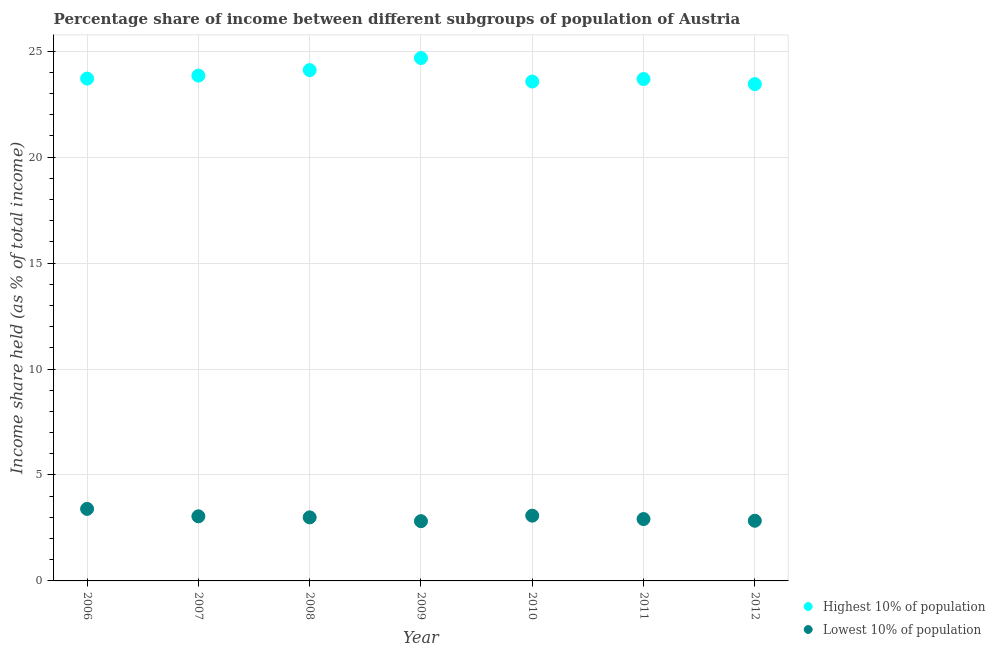How many different coloured dotlines are there?
Make the answer very short. 2. Is the number of dotlines equal to the number of legend labels?
Provide a short and direct response. Yes. What is the income share held by highest 10% of the population in 2010?
Ensure brevity in your answer.  23.57. Across all years, what is the maximum income share held by highest 10% of the population?
Give a very brief answer. 24.68. Across all years, what is the minimum income share held by highest 10% of the population?
Ensure brevity in your answer.  23.45. In which year was the income share held by highest 10% of the population maximum?
Ensure brevity in your answer.  2009. What is the total income share held by highest 10% of the population in the graph?
Offer a very short reply. 167.06. What is the difference between the income share held by lowest 10% of the population in 2008 and that in 2011?
Offer a very short reply. 0.08. What is the difference between the income share held by lowest 10% of the population in 2011 and the income share held by highest 10% of the population in 2012?
Your response must be concise. -20.53. What is the average income share held by lowest 10% of the population per year?
Your answer should be compact. 3.02. In the year 2007, what is the difference between the income share held by lowest 10% of the population and income share held by highest 10% of the population?
Your answer should be very brief. -20.8. What is the ratio of the income share held by highest 10% of the population in 2007 to that in 2009?
Your response must be concise. 0.97. Is the difference between the income share held by lowest 10% of the population in 2011 and 2012 greater than the difference between the income share held by highest 10% of the population in 2011 and 2012?
Offer a very short reply. No. What is the difference between the highest and the second highest income share held by highest 10% of the population?
Your answer should be compact. 0.57. What is the difference between the highest and the lowest income share held by lowest 10% of the population?
Provide a succinct answer. 0.58. In how many years, is the income share held by highest 10% of the population greater than the average income share held by highest 10% of the population taken over all years?
Keep it short and to the point. 2. How many dotlines are there?
Offer a terse response. 2. Are the values on the major ticks of Y-axis written in scientific E-notation?
Your response must be concise. No. Does the graph contain any zero values?
Give a very brief answer. No. Does the graph contain grids?
Your answer should be very brief. Yes. Where does the legend appear in the graph?
Your response must be concise. Bottom right. How many legend labels are there?
Offer a terse response. 2. What is the title of the graph?
Offer a terse response. Percentage share of income between different subgroups of population of Austria. What is the label or title of the X-axis?
Offer a terse response. Year. What is the label or title of the Y-axis?
Keep it short and to the point. Income share held (as % of total income). What is the Income share held (as % of total income) of Highest 10% of population in 2006?
Keep it short and to the point. 23.71. What is the Income share held (as % of total income) of Lowest 10% of population in 2006?
Give a very brief answer. 3.4. What is the Income share held (as % of total income) in Highest 10% of population in 2007?
Give a very brief answer. 23.85. What is the Income share held (as % of total income) of Lowest 10% of population in 2007?
Your answer should be compact. 3.05. What is the Income share held (as % of total income) of Highest 10% of population in 2008?
Keep it short and to the point. 24.11. What is the Income share held (as % of total income) in Lowest 10% of population in 2008?
Provide a short and direct response. 3. What is the Income share held (as % of total income) of Highest 10% of population in 2009?
Give a very brief answer. 24.68. What is the Income share held (as % of total income) of Lowest 10% of population in 2009?
Ensure brevity in your answer.  2.82. What is the Income share held (as % of total income) of Highest 10% of population in 2010?
Make the answer very short. 23.57. What is the Income share held (as % of total income) in Lowest 10% of population in 2010?
Ensure brevity in your answer.  3.08. What is the Income share held (as % of total income) in Highest 10% of population in 2011?
Your answer should be compact. 23.69. What is the Income share held (as % of total income) of Lowest 10% of population in 2011?
Your answer should be compact. 2.92. What is the Income share held (as % of total income) of Highest 10% of population in 2012?
Your answer should be very brief. 23.45. What is the Income share held (as % of total income) in Lowest 10% of population in 2012?
Your answer should be compact. 2.84. Across all years, what is the maximum Income share held (as % of total income) in Highest 10% of population?
Make the answer very short. 24.68. Across all years, what is the maximum Income share held (as % of total income) in Lowest 10% of population?
Provide a succinct answer. 3.4. Across all years, what is the minimum Income share held (as % of total income) of Highest 10% of population?
Ensure brevity in your answer.  23.45. Across all years, what is the minimum Income share held (as % of total income) of Lowest 10% of population?
Offer a very short reply. 2.82. What is the total Income share held (as % of total income) of Highest 10% of population in the graph?
Offer a terse response. 167.06. What is the total Income share held (as % of total income) in Lowest 10% of population in the graph?
Provide a short and direct response. 21.11. What is the difference between the Income share held (as % of total income) of Highest 10% of population in 2006 and that in 2007?
Make the answer very short. -0.14. What is the difference between the Income share held (as % of total income) in Lowest 10% of population in 2006 and that in 2007?
Make the answer very short. 0.35. What is the difference between the Income share held (as % of total income) in Lowest 10% of population in 2006 and that in 2008?
Offer a terse response. 0.4. What is the difference between the Income share held (as % of total income) of Highest 10% of population in 2006 and that in 2009?
Provide a short and direct response. -0.97. What is the difference between the Income share held (as % of total income) in Lowest 10% of population in 2006 and that in 2009?
Offer a very short reply. 0.58. What is the difference between the Income share held (as % of total income) in Highest 10% of population in 2006 and that in 2010?
Make the answer very short. 0.14. What is the difference between the Income share held (as % of total income) of Lowest 10% of population in 2006 and that in 2010?
Your answer should be compact. 0.32. What is the difference between the Income share held (as % of total income) of Lowest 10% of population in 2006 and that in 2011?
Ensure brevity in your answer.  0.48. What is the difference between the Income share held (as % of total income) in Highest 10% of population in 2006 and that in 2012?
Offer a terse response. 0.26. What is the difference between the Income share held (as % of total income) in Lowest 10% of population in 2006 and that in 2012?
Your response must be concise. 0.56. What is the difference between the Income share held (as % of total income) of Highest 10% of population in 2007 and that in 2008?
Make the answer very short. -0.26. What is the difference between the Income share held (as % of total income) in Highest 10% of population in 2007 and that in 2009?
Give a very brief answer. -0.83. What is the difference between the Income share held (as % of total income) in Lowest 10% of population in 2007 and that in 2009?
Make the answer very short. 0.23. What is the difference between the Income share held (as % of total income) in Highest 10% of population in 2007 and that in 2010?
Provide a short and direct response. 0.28. What is the difference between the Income share held (as % of total income) in Lowest 10% of population in 2007 and that in 2010?
Your answer should be very brief. -0.03. What is the difference between the Income share held (as % of total income) of Highest 10% of population in 2007 and that in 2011?
Offer a very short reply. 0.16. What is the difference between the Income share held (as % of total income) of Lowest 10% of population in 2007 and that in 2011?
Make the answer very short. 0.13. What is the difference between the Income share held (as % of total income) in Lowest 10% of population in 2007 and that in 2012?
Make the answer very short. 0.21. What is the difference between the Income share held (as % of total income) in Highest 10% of population in 2008 and that in 2009?
Keep it short and to the point. -0.57. What is the difference between the Income share held (as % of total income) of Lowest 10% of population in 2008 and that in 2009?
Make the answer very short. 0.18. What is the difference between the Income share held (as % of total income) of Highest 10% of population in 2008 and that in 2010?
Your answer should be very brief. 0.54. What is the difference between the Income share held (as % of total income) in Lowest 10% of population in 2008 and that in 2010?
Ensure brevity in your answer.  -0.08. What is the difference between the Income share held (as % of total income) in Highest 10% of population in 2008 and that in 2011?
Give a very brief answer. 0.42. What is the difference between the Income share held (as % of total income) of Highest 10% of population in 2008 and that in 2012?
Give a very brief answer. 0.66. What is the difference between the Income share held (as % of total income) of Lowest 10% of population in 2008 and that in 2012?
Provide a short and direct response. 0.16. What is the difference between the Income share held (as % of total income) of Highest 10% of population in 2009 and that in 2010?
Provide a succinct answer. 1.11. What is the difference between the Income share held (as % of total income) of Lowest 10% of population in 2009 and that in 2010?
Provide a succinct answer. -0.26. What is the difference between the Income share held (as % of total income) in Lowest 10% of population in 2009 and that in 2011?
Ensure brevity in your answer.  -0.1. What is the difference between the Income share held (as % of total income) of Highest 10% of population in 2009 and that in 2012?
Provide a succinct answer. 1.23. What is the difference between the Income share held (as % of total income) in Lowest 10% of population in 2009 and that in 2012?
Offer a very short reply. -0.02. What is the difference between the Income share held (as % of total income) of Highest 10% of population in 2010 and that in 2011?
Offer a very short reply. -0.12. What is the difference between the Income share held (as % of total income) of Lowest 10% of population in 2010 and that in 2011?
Offer a terse response. 0.16. What is the difference between the Income share held (as % of total income) of Highest 10% of population in 2010 and that in 2012?
Your response must be concise. 0.12. What is the difference between the Income share held (as % of total income) in Lowest 10% of population in 2010 and that in 2012?
Keep it short and to the point. 0.24. What is the difference between the Income share held (as % of total income) of Highest 10% of population in 2011 and that in 2012?
Give a very brief answer. 0.24. What is the difference between the Income share held (as % of total income) in Lowest 10% of population in 2011 and that in 2012?
Your answer should be compact. 0.08. What is the difference between the Income share held (as % of total income) of Highest 10% of population in 2006 and the Income share held (as % of total income) of Lowest 10% of population in 2007?
Your answer should be very brief. 20.66. What is the difference between the Income share held (as % of total income) of Highest 10% of population in 2006 and the Income share held (as % of total income) of Lowest 10% of population in 2008?
Provide a succinct answer. 20.71. What is the difference between the Income share held (as % of total income) of Highest 10% of population in 2006 and the Income share held (as % of total income) of Lowest 10% of population in 2009?
Ensure brevity in your answer.  20.89. What is the difference between the Income share held (as % of total income) of Highest 10% of population in 2006 and the Income share held (as % of total income) of Lowest 10% of population in 2010?
Ensure brevity in your answer.  20.63. What is the difference between the Income share held (as % of total income) in Highest 10% of population in 2006 and the Income share held (as % of total income) in Lowest 10% of population in 2011?
Your answer should be very brief. 20.79. What is the difference between the Income share held (as % of total income) in Highest 10% of population in 2006 and the Income share held (as % of total income) in Lowest 10% of population in 2012?
Provide a succinct answer. 20.87. What is the difference between the Income share held (as % of total income) in Highest 10% of population in 2007 and the Income share held (as % of total income) in Lowest 10% of population in 2008?
Ensure brevity in your answer.  20.85. What is the difference between the Income share held (as % of total income) of Highest 10% of population in 2007 and the Income share held (as % of total income) of Lowest 10% of population in 2009?
Provide a short and direct response. 21.03. What is the difference between the Income share held (as % of total income) of Highest 10% of population in 2007 and the Income share held (as % of total income) of Lowest 10% of population in 2010?
Make the answer very short. 20.77. What is the difference between the Income share held (as % of total income) of Highest 10% of population in 2007 and the Income share held (as % of total income) of Lowest 10% of population in 2011?
Give a very brief answer. 20.93. What is the difference between the Income share held (as % of total income) of Highest 10% of population in 2007 and the Income share held (as % of total income) of Lowest 10% of population in 2012?
Your response must be concise. 21.01. What is the difference between the Income share held (as % of total income) of Highest 10% of population in 2008 and the Income share held (as % of total income) of Lowest 10% of population in 2009?
Your answer should be very brief. 21.29. What is the difference between the Income share held (as % of total income) in Highest 10% of population in 2008 and the Income share held (as % of total income) in Lowest 10% of population in 2010?
Your answer should be very brief. 21.03. What is the difference between the Income share held (as % of total income) of Highest 10% of population in 2008 and the Income share held (as % of total income) of Lowest 10% of population in 2011?
Keep it short and to the point. 21.19. What is the difference between the Income share held (as % of total income) of Highest 10% of population in 2008 and the Income share held (as % of total income) of Lowest 10% of population in 2012?
Your answer should be compact. 21.27. What is the difference between the Income share held (as % of total income) in Highest 10% of population in 2009 and the Income share held (as % of total income) in Lowest 10% of population in 2010?
Offer a very short reply. 21.6. What is the difference between the Income share held (as % of total income) in Highest 10% of population in 2009 and the Income share held (as % of total income) in Lowest 10% of population in 2011?
Your answer should be very brief. 21.76. What is the difference between the Income share held (as % of total income) of Highest 10% of population in 2009 and the Income share held (as % of total income) of Lowest 10% of population in 2012?
Make the answer very short. 21.84. What is the difference between the Income share held (as % of total income) of Highest 10% of population in 2010 and the Income share held (as % of total income) of Lowest 10% of population in 2011?
Keep it short and to the point. 20.65. What is the difference between the Income share held (as % of total income) in Highest 10% of population in 2010 and the Income share held (as % of total income) in Lowest 10% of population in 2012?
Offer a terse response. 20.73. What is the difference between the Income share held (as % of total income) in Highest 10% of population in 2011 and the Income share held (as % of total income) in Lowest 10% of population in 2012?
Offer a very short reply. 20.85. What is the average Income share held (as % of total income) of Highest 10% of population per year?
Offer a very short reply. 23.87. What is the average Income share held (as % of total income) of Lowest 10% of population per year?
Keep it short and to the point. 3.02. In the year 2006, what is the difference between the Income share held (as % of total income) of Highest 10% of population and Income share held (as % of total income) of Lowest 10% of population?
Offer a very short reply. 20.31. In the year 2007, what is the difference between the Income share held (as % of total income) of Highest 10% of population and Income share held (as % of total income) of Lowest 10% of population?
Your response must be concise. 20.8. In the year 2008, what is the difference between the Income share held (as % of total income) of Highest 10% of population and Income share held (as % of total income) of Lowest 10% of population?
Provide a succinct answer. 21.11. In the year 2009, what is the difference between the Income share held (as % of total income) in Highest 10% of population and Income share held (as % of total income) in Lowest 10% of population?
Offer a very short reply. 21.86. In the year 2010, what is the difference between the Income share held (as % of total income) in Highest 10% of population and Income share held (as % of total income) in Lowest 10% of population?
Ensure brevity in your answer.  20.49. In the year 2011, what is the difference between the Income share held (as % of total income) in Highest 10% of population and Income share held (as % of total income) in Lowest 10% of population?
Your answer should be very brief. 20.77. In the year 2012, what is the difference between the Income share held (as % of total income) of Highest 10% of population and Income share held (as % of total income) of Lowest 10% of population?
Provide a succinct answer. 20.61. What is the ratio of the Income share held (as % of total income) in Highest 10% of population in 2006 to that in 2007?
Make the answer very short. 0.99. What is the ratio of the Income share held (as % of total income) in Lowest 10% of population in 2006 to that in 2007?
Give a very brief answer. 1.11. What is the ratio of the Income share held (as % of total income) of Highest 10% of population in 2006 to that in 2008?
Provide a short and direct response. 0.98. What is the ratio of the Income share held (as % of total income) in Lowest 10% of population in 2006 to that in 2008?
Make the answer very short. 1.13. What is the ratio of the Income share held (as % of total income) in Highest 10% of population in 2006 to that in 2009?
Provide a succinct answer. 0.96. What is the ratio of the Income share held (as % of total income) of Lowest 10% of population in 2006 to that in 2009?
Offer a terse response. 1.21. What is the ratio of the Income share held (as % of total income) of Highest 10% of population in 2006 to that in 2010?
Your answer should be compact. 1.01. What is the ratio of the Income share held (as % of total income) in Lowest 10% of population in 2006 to that in 2010?
Provide a succinct answer. 1.1. What is the ratio of the Income share held (as % of total income) of Lowest 10% of population in 2006 to that in 2011?
Your answer should be very brief. 1.16. What is the ratio of the Income share held (as % of total income) of Highest 10% of population in 2006 to that in 2012?
Your answer should be very brief. 1.01. What is the ratio of the Income share held (as % of total income) in Lowest 10% of population in 2006 to that in 2012?
Offer a very short reply. 1.2. What is the ratio of the Income share held (as % of total income) in Highest 10% of population in 2007 to that in 2008?
Your answer should be very brief. 0.99. What is the ratio of the Income share held (as % of total income) of Lowest 10% of population in 2007 to that in 2008?
Your response must be concise. 1.02. What is the ratio of the Income share held (as % of total income) of Highest 10% of population in 2007 to that in 2009?
Give a very brief answer. 0.97. What is the ratio of the Income share held (as % of total income) of Lowest 10% of population in 2007 to that in 2009?
Offer a terse response. 1.08. What is the ratio of the Income share held (as % of total income) of Highest 10% of population in 2007 to that in 2010?
Ensure brevity in your answer.  1.01. What is the ratio of the Income share held (as % of total income) in Lowest 10% of population in 2007 to that in 2010?
Offer a very short reply. 0.99. What is the ratio of the Income share held (as % of total income) in Highest 10% of population in 2007 to that in 2011?
Give a very brief answer. 1.01. What is the ratio of the Income share held (as % of total income) of Lowest 10% of population in 2007 to that in 2011?
Make the answer very short. 1.04. What is the ratio of the Income share held (as % of total income) of Highest 10% of population in 2007 to that in 2012?
Make the answer very short. 1.02. What is the ratio of the Income share held (as % of total income) in Lowest 10% of population in 2007 to that in 2012?
Your answer should be very brief. 1.07. What is the ratio of the Income share held (as % of total income) in Highest 10% of population in 2008 to that in 2009?
Provide a short and direct response. 0.98. What is the ratio of the Income share held (as % of total income) of Lowest 10% of population in 2008 to that in 2009?
Your answer should be very brief. 1.06. What is the ratio of the Income share held (as % of total income) of Highest 10% of population in 2008 to that in 2010?
Your answer should be very brief. 1.02. What is the ratio of the Income share held (as % of total income) of Lowest 10% of population in 2008 to that in 2010?
Your response must be concise. 0.97. What is the ratio of the Income share held (as % of total income) in Highest 10% of population in 2008 to that in 2011?
Offer a very short reply. 1.02. What is the ratio of the Income share held (as % of total income) of Lowest 10% of population in 2008 to that in 2011?
Provide a short and direct response. 1.03. What is the ratio of the Income share held (as % of total income) in Highest 10% of population in 2008 to that in 2012?
Keep it short and to the point. 1.03. What is the ratio of the Income share held (as % of total income) in Lowest 10% of population in 2008 to that in 2012?
Your answer should be compact. 1.06. What is the ratio of the Income share held (as % of total income) in Highest 10% of population in 2009 to that in 2010?
Provide a succinct answer. 1.05. What is the ratio of the Income share held (as % of total income) in Lowest 10% of population in 2009 to that in 2010?
Your answer should be compact. 0.92. What is the ratio of the Income share held (as % of total income) in Highest 10% of population in 2009 to that in 2011?
Give a very brief answer. 1.04. What is the ratio of the Income share held (as % of total income) of Lowest 10% of population in 2009 to that in 2011?
Your answer should be very brief. 0.97. What is the ratio of the Income share held (as % of total income) of Highest 10% of population in 2009 to that in 2012?
Offer a terse response. 1.05. What is the ratio of the Income share held (as % of total income) of Lowest 10% of population in 2009 to that in 2012?
Offer a terse response. 0.99. What is the ratio of the Income share held (as % of total income) of Lowest 10% of population in 2010 to that in 2011?
Your answer should be very brief. 1.05. What is the ratio of the Income share held (as % of total income) in Highest 10% of population in 2010 to that in 2012?
Offer a very short reply. 1.01. What is the ratio of the Income share held (as % of total income) of Lowest 10% of population in 2010 to that in 2012?
Your response must be concise. 1.08. What is the ratio of the Income share held (as % of total income) of Highest 10% of population in 2011 to that in 2012?
Ensure brevity in your answer.  1.01. What is the ratio of the Income share held (as % of total income) in Lowest 10% of population in 2011 to that in 2012?
Keep it short and to the point. 1.03. What is the difference between the highest and the second highest Income share held (as % of total income) in Highest 10% of population?
Ensure brevity in your answer.  0.57. What is the difference between the highest and the second highest Income share held (as % of total income) in Lowest 10% of population?
Offer a very short reply. 0.32. What is the difference between the highest and the lowest Income share held (as % of total income) of Highest 10% of population?
Offer a terse response. 1.23. What is the difference between the highest and the lowest Income share held (as % of total income) in Lowest 10% of population?
Ensure brevity in your answer.  0.58. 